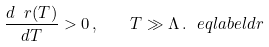<formula> <loc_0><loc_0><loc_500><loc_500>\frac { d \ r ( T ) } { d T } > 0 \, , \quad T \gg \Lambda \, . \ e q l a b e l { d r }</formula> 